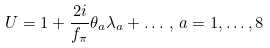Convert formula to latex. <formula><loc_0><loc_0><loc_500><loc_500>U = 1 + \frac { 2 i } { f _ { \pi } } \theta _ { a } \lambda _ { a } + \dots \, , \, a = 1 , \dots , 8</formula> 